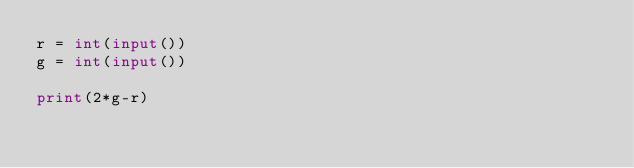<code> <loc_0><loc_0><loc_500><loc_500><_Python_>r = int(input())
g = int(input())

print(2*g-r)</code> 